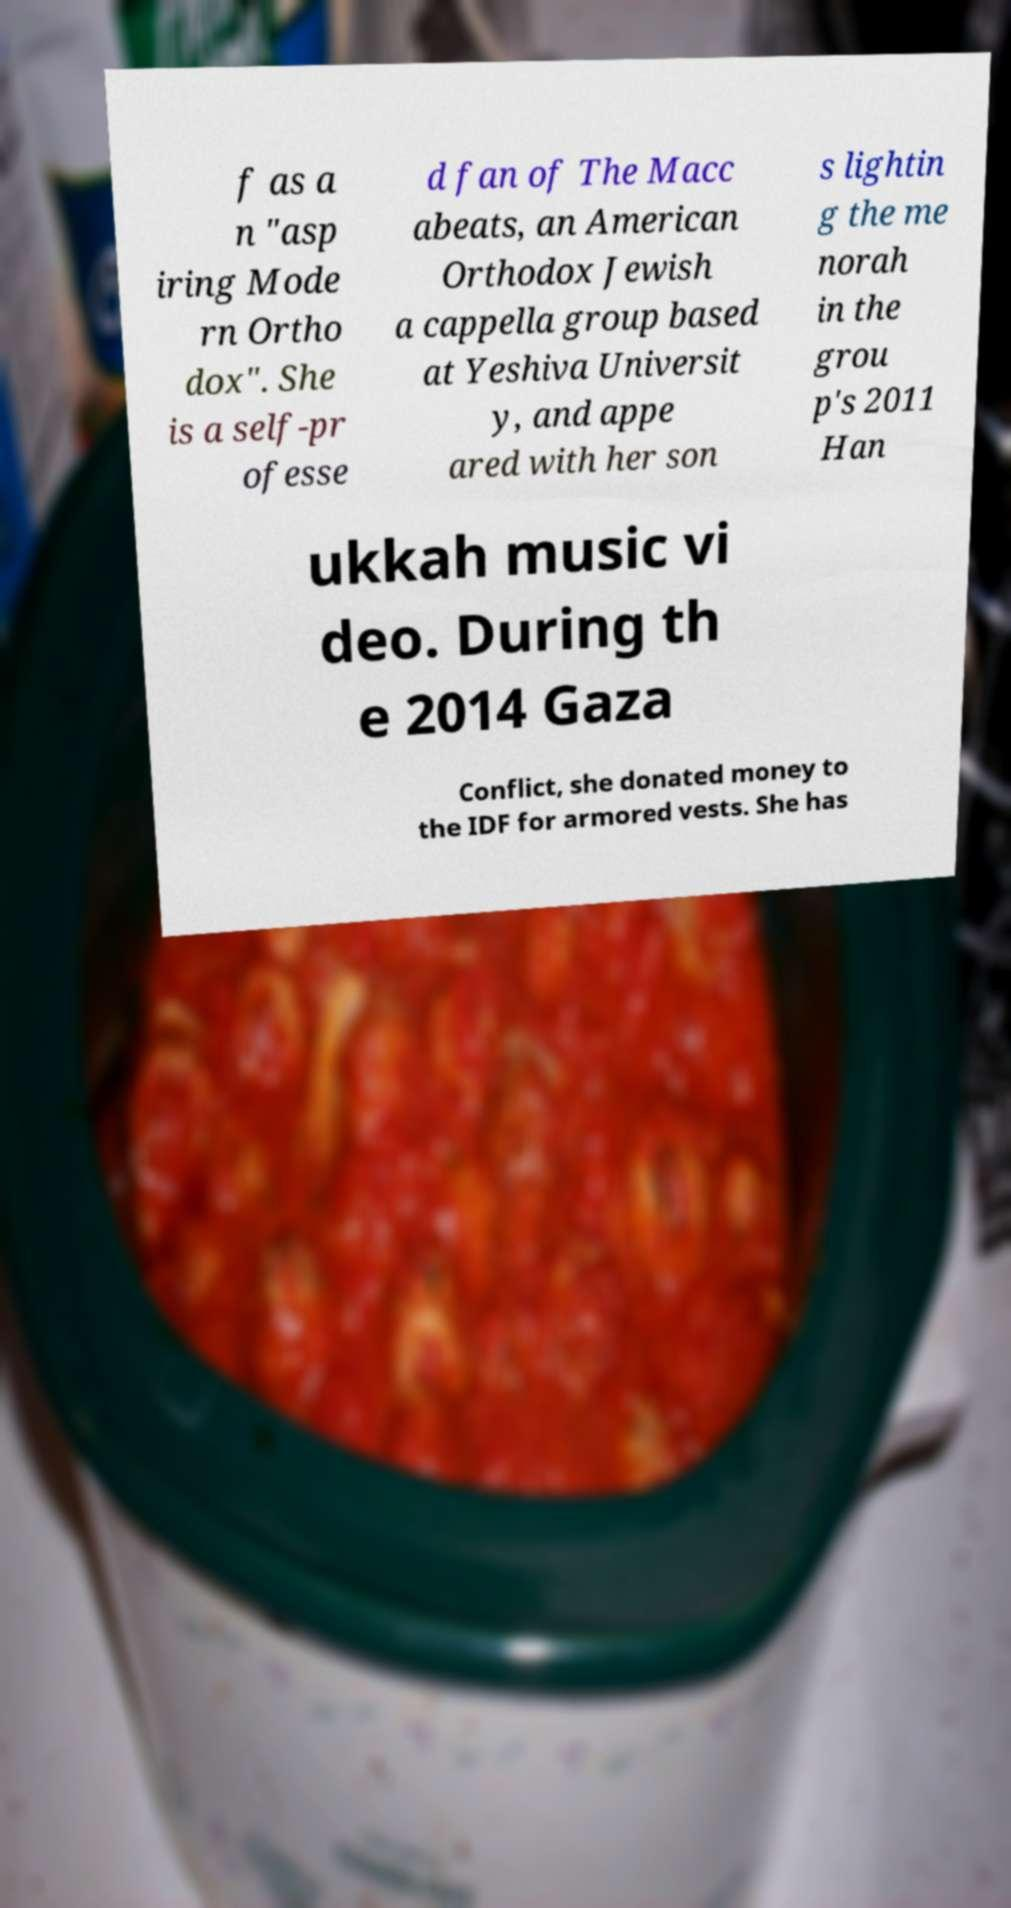What messages or text are displayed in this image? I need them in a readable, typed format. f as a n "asp iring Mode rn Ortho dox". She is a self-pr ofesse d fan of The Macc abeats, an American Orthodox Jewish a cappella group based at Yeshiva Universit y, and appe ared with her son s lightin g the me norah in the grou p's 2011 Han ukkah music vi deo. During th e 2014 Gaza Conflict, she donated money to the IDF for armored vests. She has 